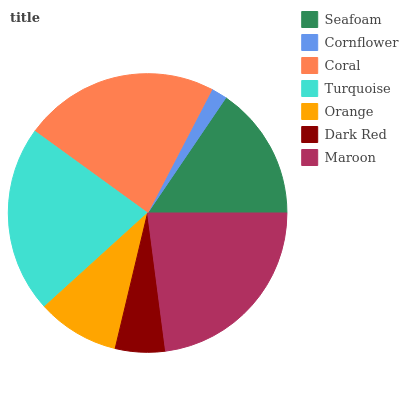Is Cornflower the minimum?
Answer yes or no. Yes. Is Maroon the maximum?
Answer yes or no. Yes. Is Coral the minimum?
Answer yes or no. No. Is Coral the maximum?
Answer yes or no. No. Is Coral greater than Cornflower?
Answer yes or no. Yes. Is Cornflower less than Coral?
Answer yes or no. Yes. Is Cornflower greater than Coral?
Answer yes or no. No. Is Coral less than Cornflower?
Answer yes or no. No. Is Seafoam the high median?
Answer yes or no. Yes. Is Seafoam the low median?
Answer yes or no. Yes. Is Cornflower the high median?
Answer yes or no. No. Is Turquoise the low median?
Answer yes or no. No. 